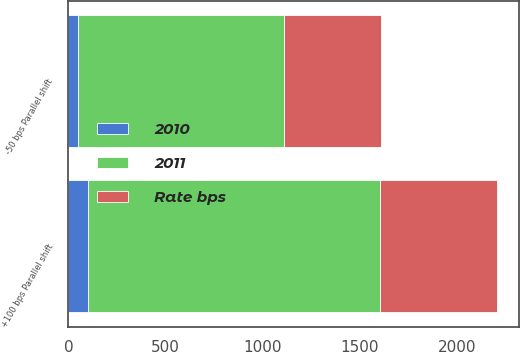<chart> <loc_0><loc_0><loc_500><loc_500><stacked_bar_chart><ecel><fcel>+100 bps Parallel shift<fcel>-50 bps Parallel shift<nl><fcel>2010<fcel>100<fcel>50<nl><fcel>2011<fcel>1505<fcel>1061<nl><fcel>Rate bps<fcel>601<fcel>499<nl></chart> 